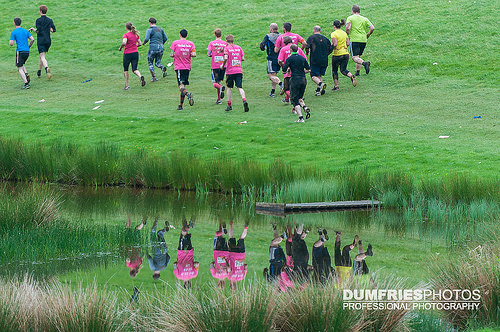<image>
Is the shirt in front of the man? No. The shirt is not in front of the man. The spatial positioning shows a different relationship between these objects. 